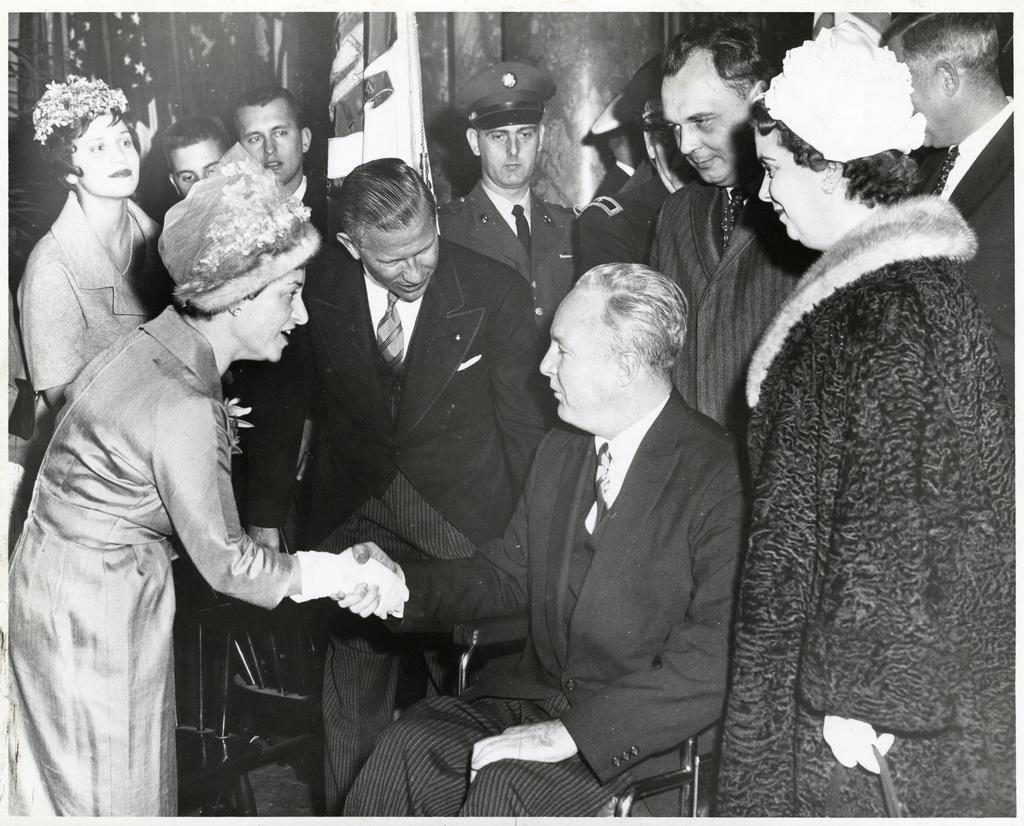In one or two sentences, can you explain what this image depicts? This picture shows few people Standing and we see a man seated and we see a women shaking hand with the man and we see few of them wore caps on their heads and we see a flag on the side. 